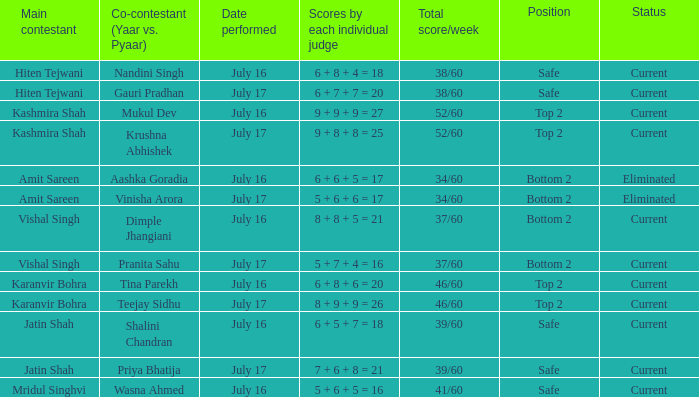In which position did pranita sahu's team end up? Bottom 2. 